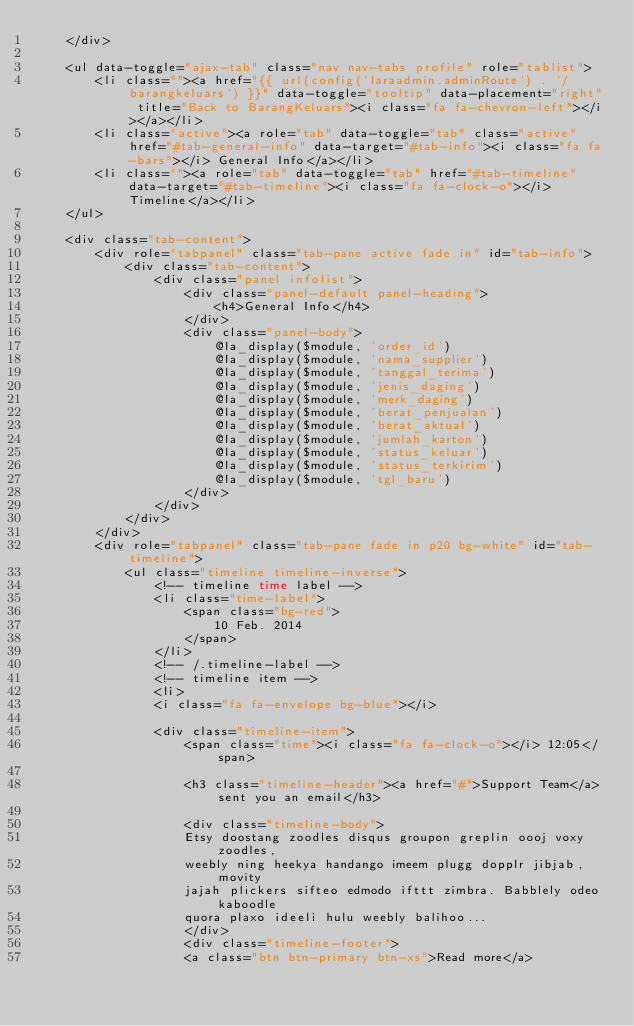Convert code to text. <code><loc_0><loc_0><loc_500><loc_500><_PHP_>	</div>

	<ul data-toggle="ajax-tab" class="nav nav-tabs profile" role="tablist">
		<li class=""><a href="{{ url(config('laraadmin.adminRoute') . '/barangkeluars') }}" data-toggle="tooltip" data-placement="right" title="Back to BarangKeluars"><i class="fa fa-chevron-left"></i></a></li>
		<li class="active"><a role="tab" data-toggle="tab" class="active" href="#tab-general-info" data-target="#tab-info"><i class="fa fa-bars"></i> General Info</a></li>
		<li class=""><a role="tab" data-toggle="tab" href="#tab-timeline" data-target="#tab-timeline"><i class="fa fa-clock-o"></i> Timeline</a></li>
	</ul>

	<div class="tab-content">
		<div role="tabpanel" class="tab-pane active fade in" id="tab-info">
			<div class="tab-content">
				<div class="panel infolist">
					<div class="panel-default panel-heading">
						<h4>General Info</h4>
					</div>
					<div class="panel-body">
						@la_display($module, 'order_id')
						@la_display($module, 'nama_supplier')
						@la_display($module, 'tanggal_terima')
						@la_display($module, 'jenis_daging')
						@la_display($module, 'merk_daging')
						@la_display($module, 'berat_penjualan')
						@la_display($module, 'berat_aktual')
						@la_display($module, 'jumlah_karton')
						@la_display($module, 'status_keluar')
						@la_display($module, 'status_terkirim')
						@la_display($module, 'tgl_baru')
					</div>
				</div>
			</div>
		</div>
		<div role="tabpanel" class="tab-pane fade in p20 bg-white" id="tab-timeline">
			<ul class="timeline timeline-inverse">
				<!-- timeline time label -->
				<li class="time-label">
					<span class="bg-red">
						10 Feb. 2014
					</span>
				</li>
				<!-- /.timeline-label -->
				<!-- timeline item -->
				<li>
				<i class="fa fa-envelope bg-blue"></i>

				<div class="timeline-item">
					<span class="time"><i class="fa fa-clock-o"></i> 12:05</span>

					<h3 class="timeline-header"><a href="#">Support Team</a> sent you an email</h3>

					<div class="timeline-body">
					Etsy doostang zoodles disqus groupon greplin oooj voxy zoodles,
					weebly ning heekya handango imeem plugg dopplr jibjab, movity
					jajah plickers sifteo edmodo ifttt zimbra. Babblely odeo kaboodle
					quora plaxo ideeli hulu weebly balihoo...
					</div>
					<div class="timeline-footer">
					<a class="btn btn-primary btn-xs">Read more</a></code> 